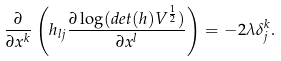Convert formula to latex. <formula><loc_0><loc_0><loc_500><loc_500>\frac { \partial } { \partial x ^ { k } } \left ( h _ { l j } \frac { \partial \log ( d e t ( h ) V ^ { \frac { 1 } { 2 } } ) } { \partial x ^ { l } } \right ) = - 2 \lambda \delta ^ { k } _ { j } .</formula> 